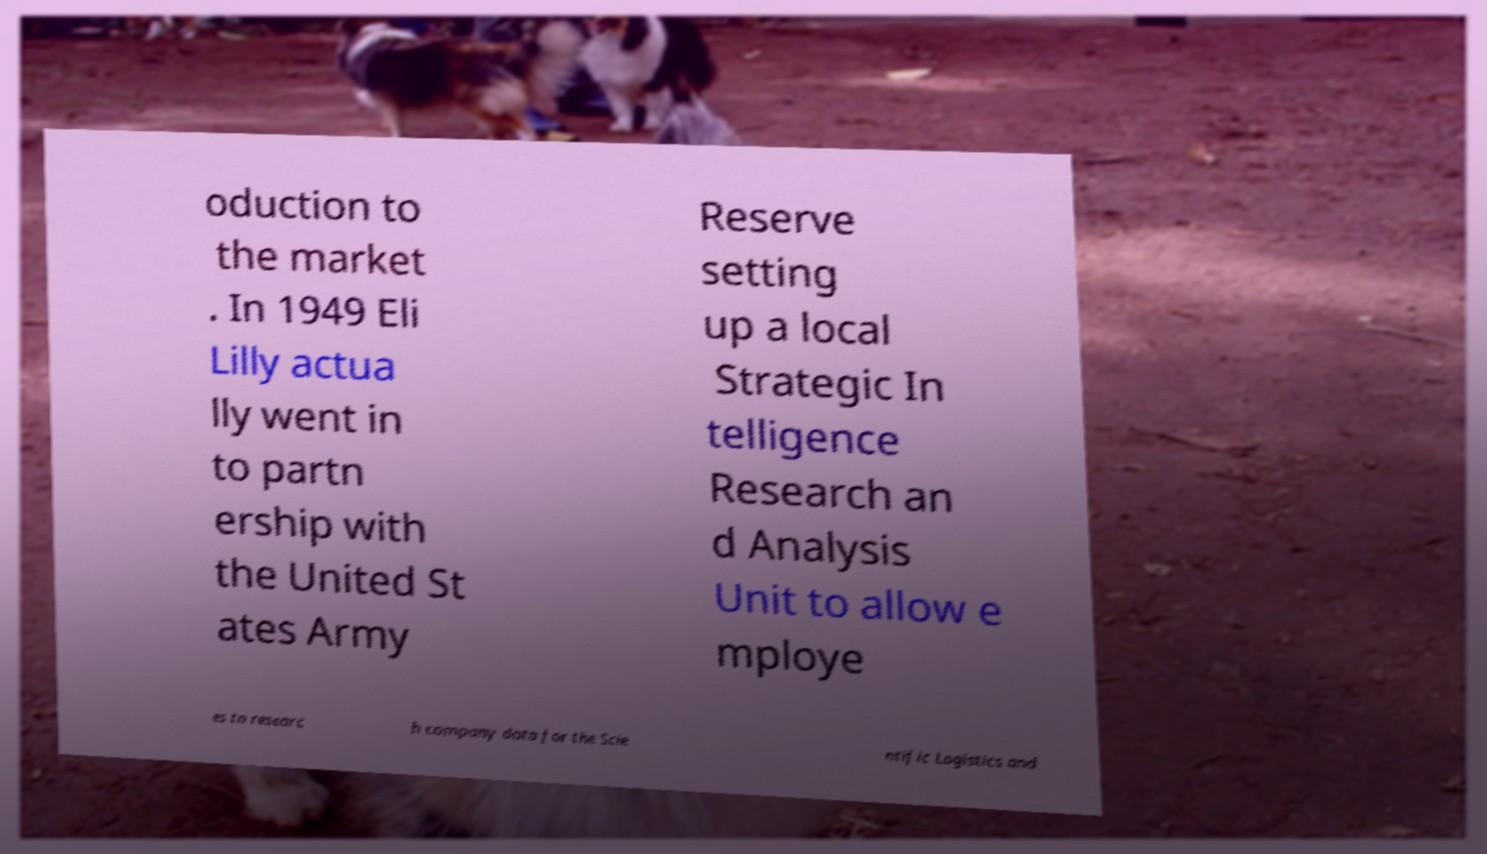Please read and relay the text visible in this image. What does it say? oduction to the market . In 1949 Eli Lilly actua lly went in to partn ership with the United St ates Army Reserve setting up a local Strategic In telligence Research an d Analysis Unit to allow e mploye es to researc h company data for the Scie ntific Logistics and 